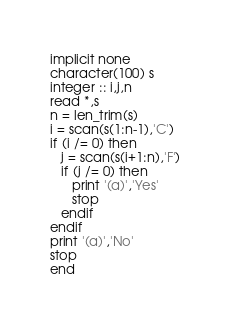<code> <loc_0><loc_0><loc_500><loc_500><_FORTRAN_>implicit none
character(100) s
integer :: i,j,n
read *,s
n = len_trim(s)
i = scan(s(1:n-1),'C')
if (i /= 0) then
   j = scan(s(i+1:n),'F')
   if (j /= 0) then
      print '(a)','Yes'
      stop
   endif
endif
print '(a)','No'
stop
end</code> 